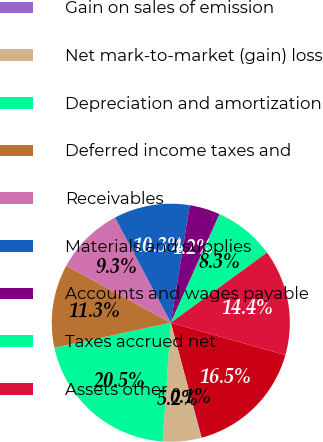Convert chart. <chart><loc_0><loc_0><loc_500><loc_500><pie_chart><fcel>Net income<fcel>Gain on sales of emission<fcel>Net mark-to-market (gain) loss<fcel>Depreciation and amortization<fcel>Deferred income taxes and<fcel>Receivables<fcel>Materials and supplies<fcel>Accounts and wages payable<fcel>Taxes accrued net<fcel>Assets other<nl><fcel>16.45%<fcel>0.07%<fcel>5.19%<fcel>20.54%<fcel>11.33%<fcel>9.28%<fcel>10.31%<fcel>4.17%<fcel>8.26%<fcel>14.4%<nl></chart> 